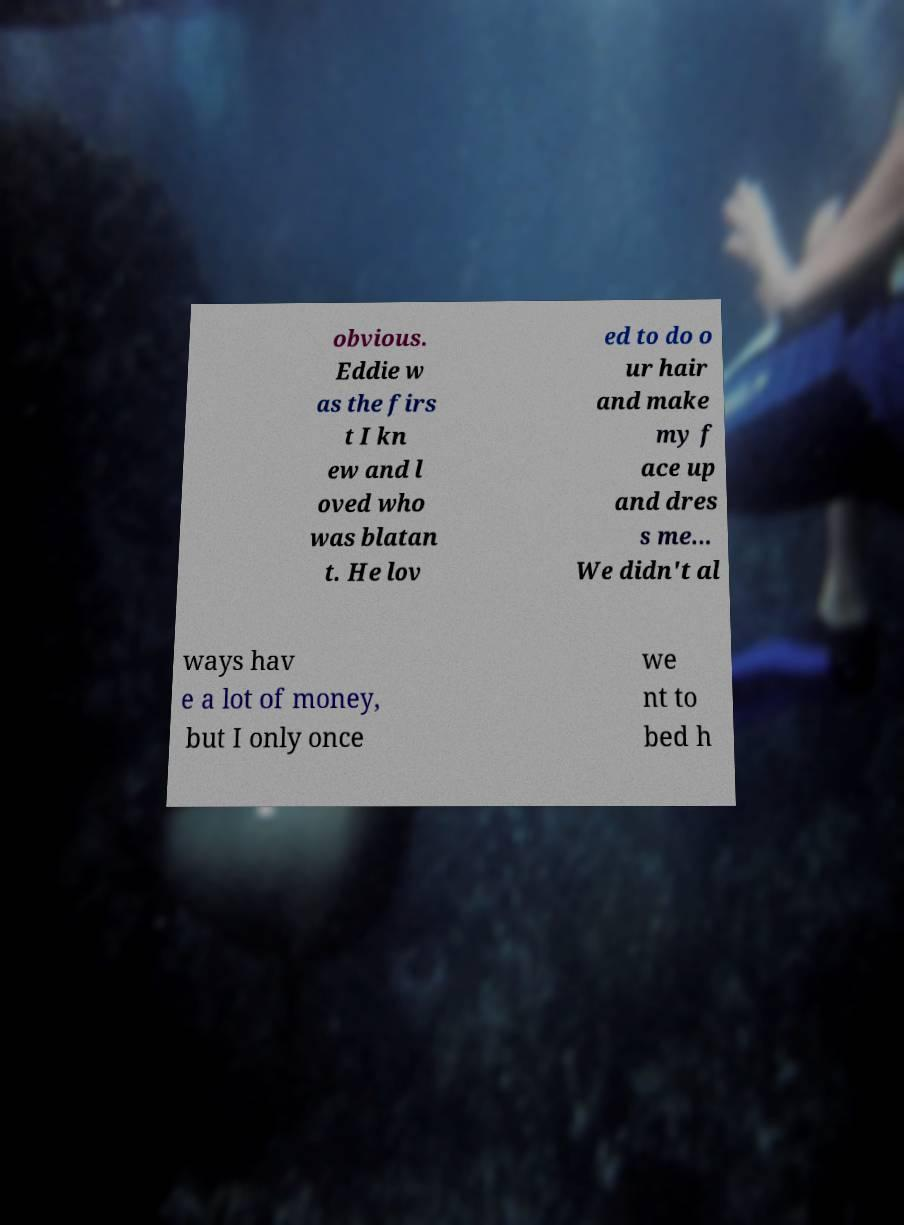There's text embedded in this image that I need extracted. Can you transcribe it verbatim? obvious. Eddie w as the firs t I kn ew and l oved who was blatan t. He lov ed to do o ur hair and make my f ace up and dres s me... We didn't al ways hav e a lot of money, but I only once we nt to bed h 